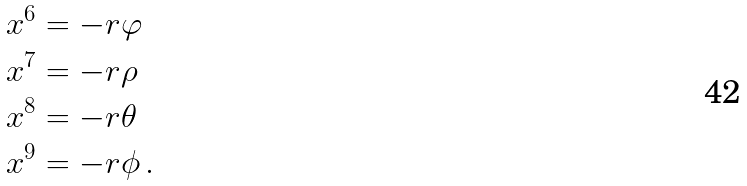<formula> <loc_0><loc_0><loc_500><loc_500>x ^ { 6 } & = - r \varphi \\ x ^ { 7 } & = - r \rho \\ x ^ { 8 } & = - r \theta \\ x ^ { 9 } & = - r \phi \, .</formula> 